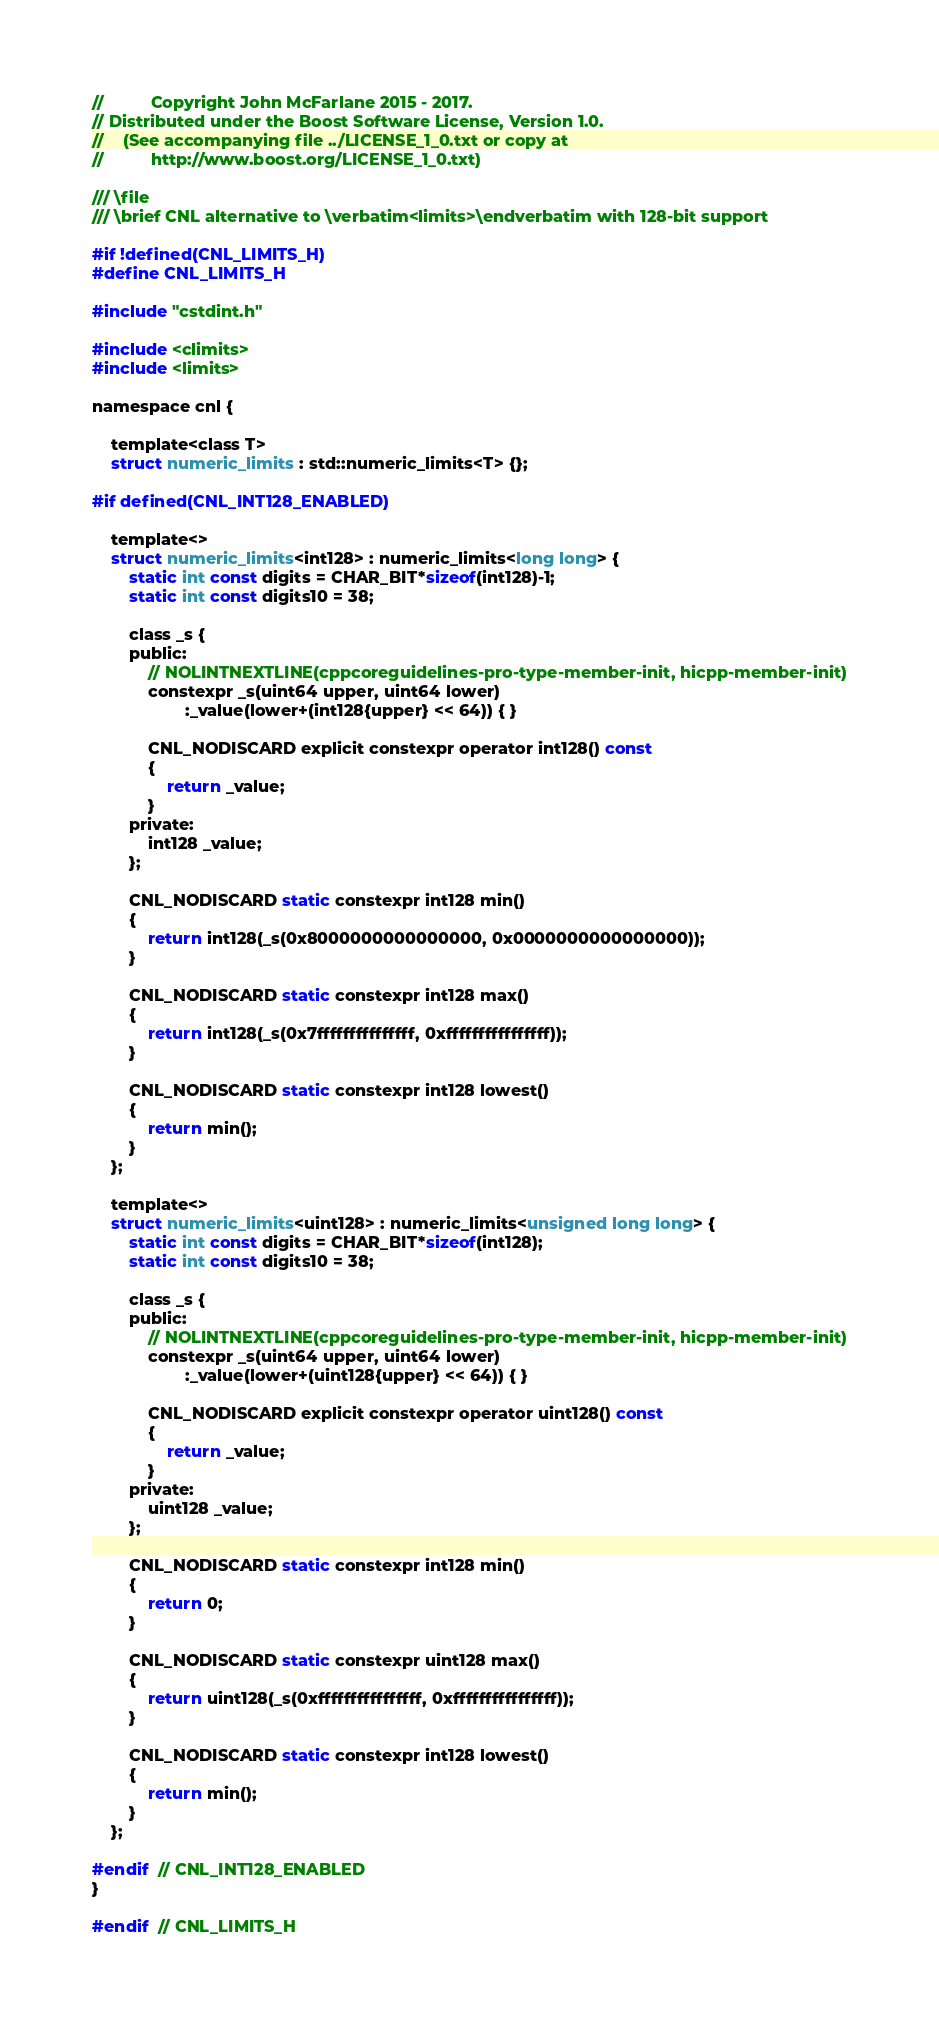Convert code to text. <code><loc_0><loc_0><loc_500><loc_500><_C_>
//          Copyright John McFarlane 2015 - 2017.
// Distributed under the Boost Software License, Version 1.0.
//    (See accompanying file ../LICENSE_1_0.txt or copy at
//          http://www.boost.org/LICENSE_1_0.txt)

/// \file
/// \brief CNL alternative to \verbatim<limits>\endverbatim with 128-bit support

#if !defined(CNL_LIMITS_H)
#define CNL_LIMITS_H

#include "cstdint.h"

#include <climits>
#include <limits>

namespace cnl {

    template<class T>
    struct numeric_limits : std::numeric_limits<T> {};

#if defined(CNL_INT128_ENABLED)

    template<>
    struct numeric_limits<int128> : numeric_limits<long long> {
        static int const digits = CHAR_BIT*sizeof(int128)-1;
        static int const digits10 = 38;

        class _s {
        public:
            // NOLINTNEXTLINE(cppcoreguidelines-pro-type-member-init, hicpp-member-init)
            constexpr _s(uint64 upper, uint64 lower)
                    :_value(lower+(int128{upper} << 64)) { }

            CNL_NODISCARD explicit constexpr operator int128() const
            {
                return _value;
            }
        private:
            int128 _value;
        };

        CNL_NODISCARD static constexpr int128 min()
        {
            return int128(_s(0x8000000000000000, 0x0000000000000000));
        }

        CNL_NODISCARD static constexpr int128 max()
        {
            return int128(_s(0x7fffffffffffffff, 0xffffffffffffffff));
        }

        CNL_NODISCARD static constexpr int128 lowest()
        {
            return min();
        }
    };

    template<>
    struct numeric_limits<uint128> : numeric_limits<unsigned long long> {
        static int const digits = CHAR_BIT*sizeof(int128);
        static int const digits10 = 38;

        class _s {
        public:
            // NOLINTNEXTLINE(cppcoreguidelines-pro-type-member-init, hicpp-member-init)
            constexpr _s(uint64 upper, uint64 lower)
                    :_value(lower+(uint128{upper} << 64)) { }

            CNL_NODISCARD explicit constexpr operator uint128() const
            {
                return _value;
            }
        private:
            uint128 _value;
        };

        CNL_NODISCARD static constexpr int128 min()
        {
            return 0;
        }

        CNL_NODISCARD static constexpr uint128 max()
        {
            return uint128(_s(0xffffffffffffffff, 0xffffffffffffffff));
        }

        CNL_NODISCARD static constexpr int128 lowest()
        {
            return min();
        }
    };

#endif  // CNL_INT128_ENABLED
}

#endif  // CNL_LIMITS_H
</code> 